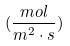<formula> <loc_0><loc_0><loc_500><loc_500>( \frac { m o l } { m ^ { 2 } \cdot s } )</formula> 